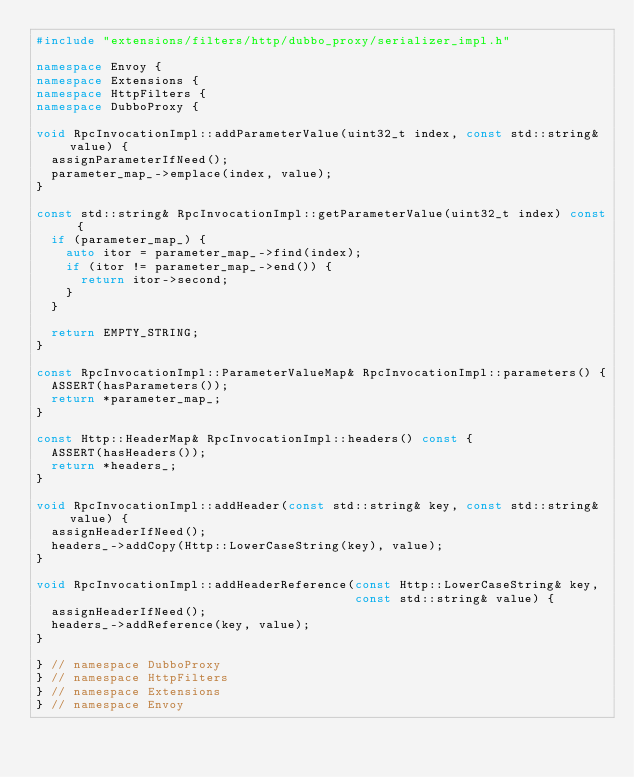<code> <loc_0><loc_0><loc_500><loc_500><_C++_>#include "extensions/filters/http/dubbo_proxy/serializer_impl.h"

namespace Envoy {
namespace Extensions {
namespace HttpFilters {
namespace DubboProxy {

void RpcInvocationImpl::addParameterValue(uint32_t index, const std::string& value) {
  assignParameterIfNeed();
  parameter_map_->emplace(index, value);
}

const std::string& RpcInvocationImpl::getParameterValue(uint32_t index) const {
  if (parameter_map_) {
    auto itor = parameter_map_->find(index);
    if (itor != parameter_map_->end()) {
      return itor->second;
    }
  }

  return EMPTY_STRING;
}

const RpcInvocationImpl::ParameterValueMap& RpcInvocationImpl::parameters() {
  ASSERT(hasParameters());
  return *parameter_map_;
}

const Http::HeaderMap& RpcInvocationImpl::headers() const {
  ASSERT(hasHeaders());
  return *headers_;
}

void RpcInvocationImpl::addHeader(const std::string& key, const std::string& value) {
  assignHeaderIfNeed();
  headers_->addCopy(Http::LowerCaseString(key), value);
}

void RpcInvocationImpl::addHeaderReference(const Http::LowerCaseString& key,
                                           const std::string& value) {
  assignHeaderIfNeed();
  headers_->addReference(key, value);
}

} // namespace DubboProxy
} // namespace HttpFilters
} // namespace Extensions
} // namespace Envoy
</code> 